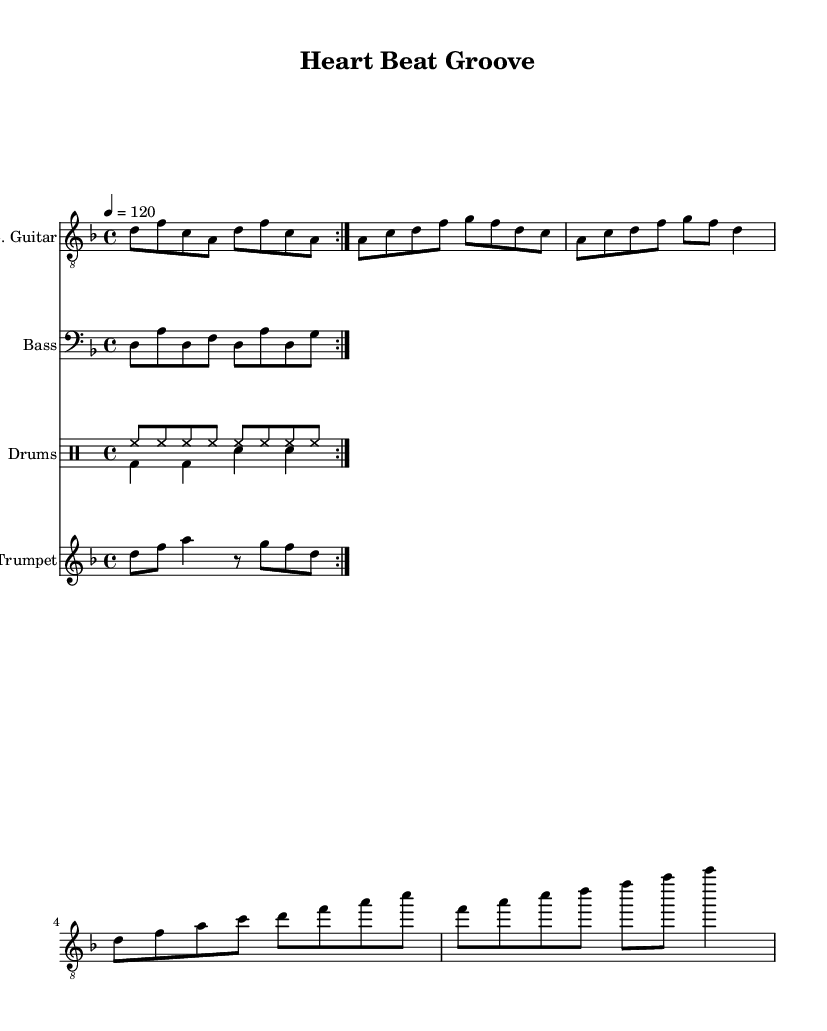What is the key signature of this music? The key signature is two flats, indicating D minor. We can determine this from the notation on the staff, where two flats appear at the beginning.
Answer: D minor What is the time signature of this piece? The time signature is four-four, which is indicated at the beginning of the score with a '4/4' sign. This means there are four beats in each measure.
Answer: 4/4 What is the tempo marking for this music? The tempo of the piece is marked at 120 beats per minute, shown by '4 = 120' at the top of the score. This indicates a moderate speed.
Answer: 120 How many measures are in the electric guitar part? The electric guitar part has a total of ten measures, as counted from the notation provided on the staff for the guitar.
Answer: 10 What instruments are featured in this composition? The score features four instruments: electric guitar, bass, drums, and trumpet, which are all noted in their respective staves in the score.
Answer: Electric guitar, bass, drums, trumpet What kind of groove does the drum pattern suggest? The drum patterns create an upbeat and lively groove typical of funk music, with a combination of hi-hat and bass drum patterns that suggest energetic rhythm.
Answer: Energetic groove Describe the rhythmic emphasis in the trumpet part. The trumpet part mainly features eighth and quarter notes, with rhythmic emphasis on certain notes that contribute to the funk style, particularly the syncopated rhythm.
Answer: Syncopated rhythm 